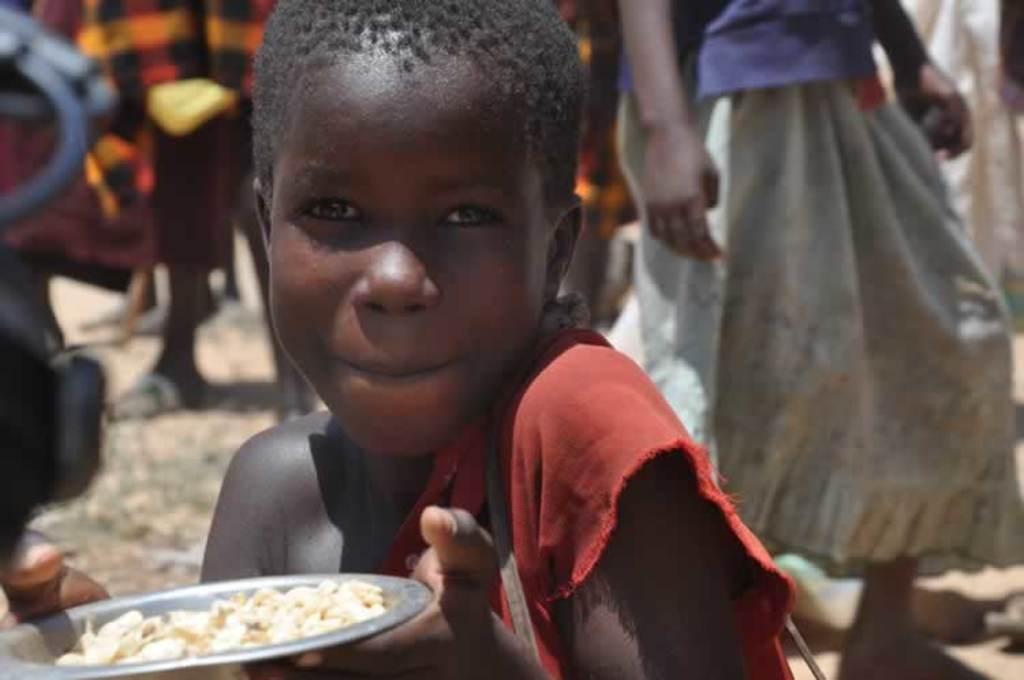Can you describe this image briefly? In this image I can see a person wearing red color dress is holding a plate with food item in it. In the background I can see few other persons standing. 